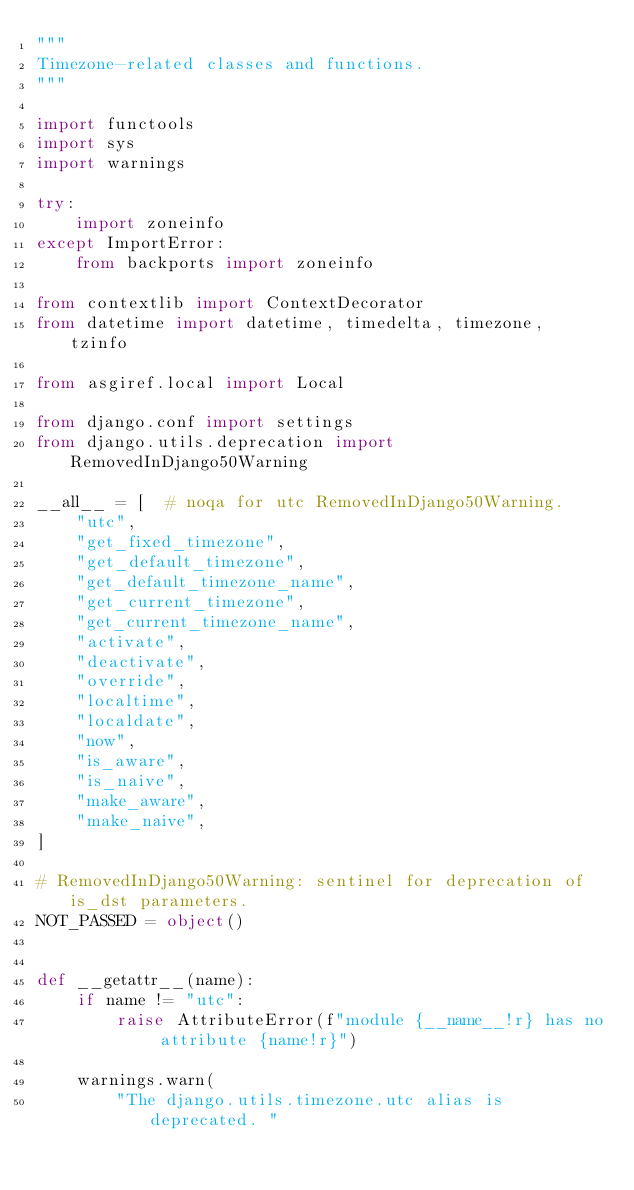Convert code to text. <code><loc_0><loc_0><loc_500><loc_500><_Python_>"""
Timezone-related classes and functions.
"""

import functools
import sys
import warnings

try:
    import zoneinfo
except ImportError:
    from backports import zoneinfo

from contextlib import ContextDecorator
from datetime import datetime, timedelta, timezone, tzinfo

from asgiref.local import Local

from django.conf import settings
from django.utils.deprecation import RemovedInDjango50Warning

__all__ = [  # noqa for utc RemovedInDjango50Warning.
    "utc",
    "get_fixed_timezone",
    "get_default_timezone",
    "get_default_timezone_name",
    "get_current_timezone",
    "get_current_timezone_name",
    "activate",
    "deactivate",
    "override",
    "localtime",
    "localdate",
    "now",
    "is_aware",
    "is_naive",
    "make_aware",
    "make_naive",
]

# RemovedInDjango50Warning: sentinel for deprecation of is_dst parameters.
NOT_PASSED = object()


def __getattr__(name):
    if name != "utc":
        raise AttributeError(f"module {__name__!r} has no attribute {name!r}")

    warnings.warn(
        "The django.utils.timezone.utc alias is deprecated. "</code> 